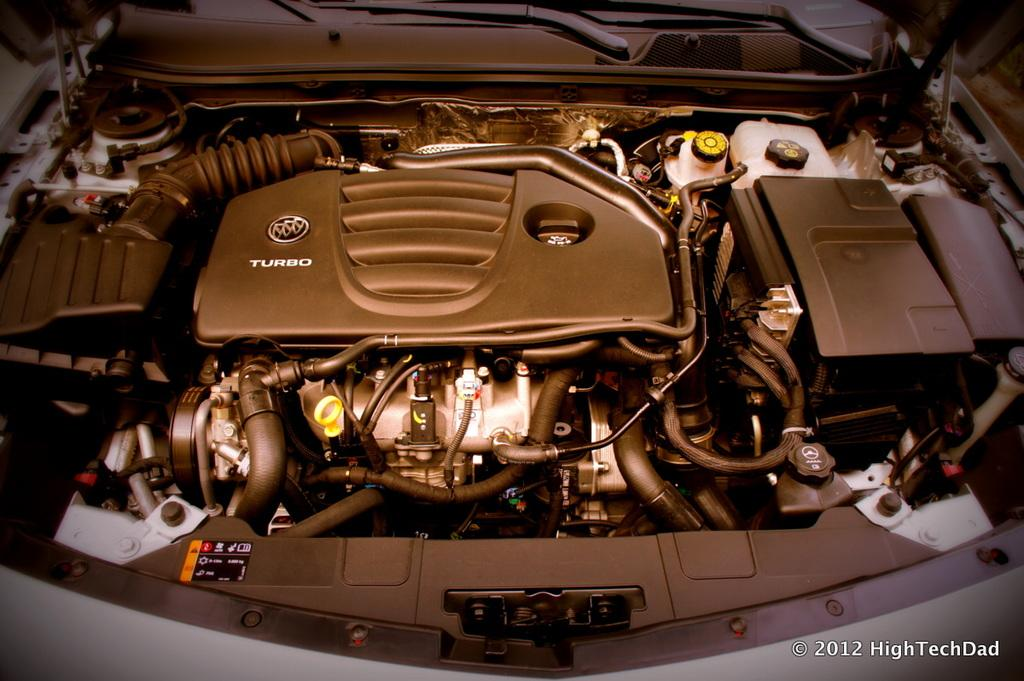<image>
Describe the image concisely. HighTechDad took a picture of a Buick TURBO engine 